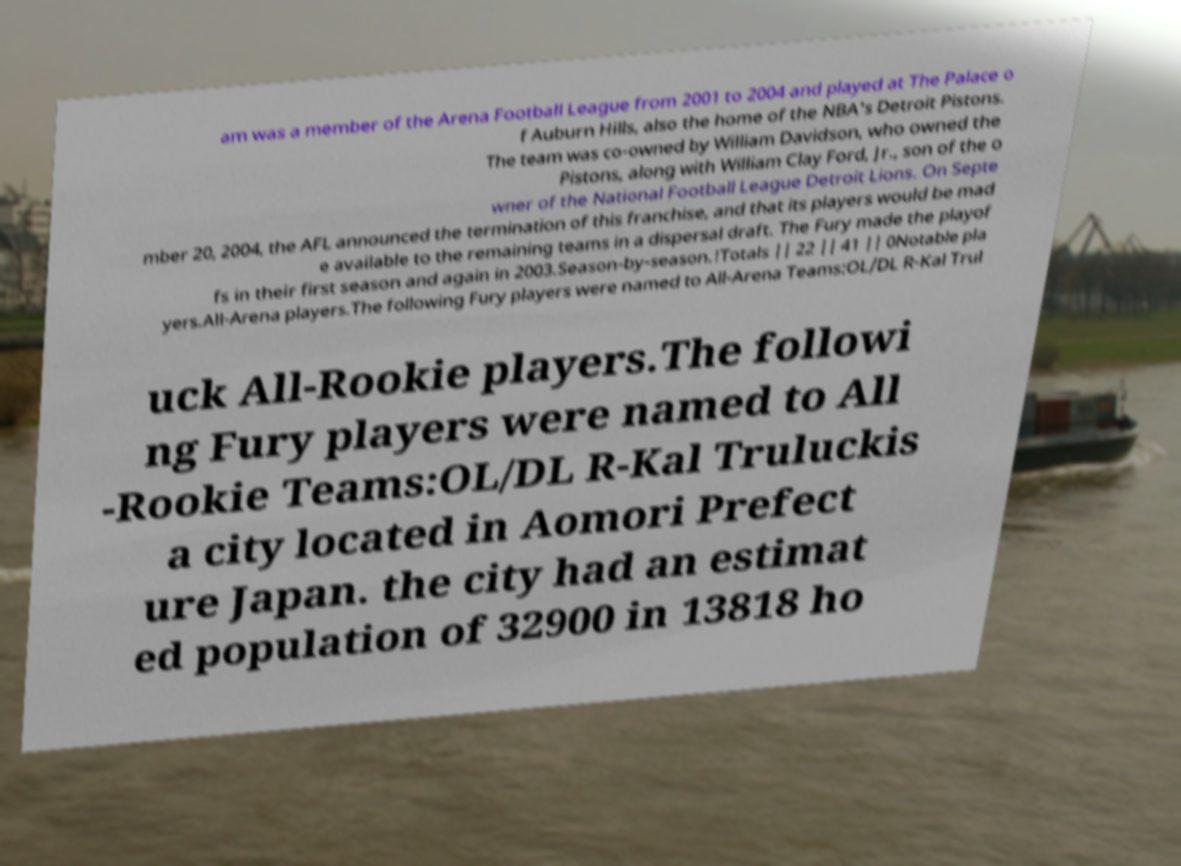I need the written content from this picture converted into text. Can you do that? am was a member of the Arena Football League from 2001 to 2004 and played at The Palace o f Auburn Hills, also the home of the NBA's Detroit Pistons. The team was co-owned by William Davidson, who owned the Pistons, along with William Clay Ford, Jr., son of the o wner of the National Football League Detroit Lions. On Septe mber 20, 2004, the AFL announced the termination of this franchise, and that its players would be mad e available to the remaining teams in a dispersal draft. The Fury made the playof fs in their first season and again in 2003.Season-by-season.!Totals || 22 || 41 || 0Notable pla yers.All-Arena players.The following Fury players were named to All-Arena Teams:OL/DL R-Kal Trul uck All-Rookie players.The followi ng Fury players were named to All -Rookie Teams:OL/DL R-Kal Truluckis a city located in Aomori Prefect ure Japan. the city had an estimat ed population of 32900 in 13818 ho 